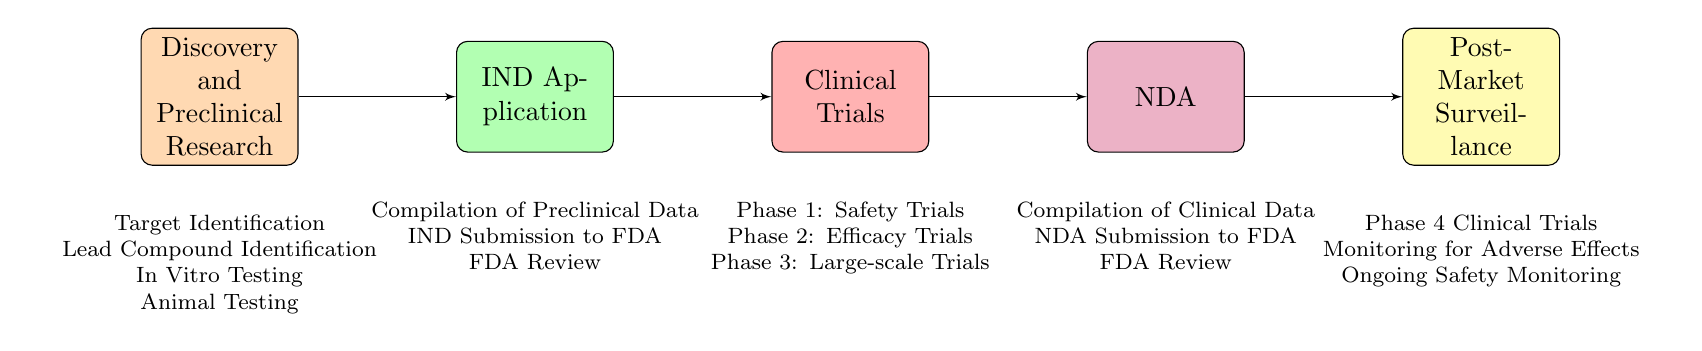What is the first stage in the drug development process? The diagram clearly lists "Discovery and Preclinical Research" as the first stage, as it is positioned leftmost in the flow chart and is not preceded by any other stage.
Answer: Discovery and Preclinical Research How many phases are involved in Clinical Trials? The Clinical Trials stage contains three distinct phases: Phase 1, Phase 2, and Phase 3, which are specifically enumerated in the diagram beneath this stage.
Answer: Three What is the last stage of the drug development process? The last stage is indicated by the rightmost block of the flow chart, which is "Post-Market Surveillance," signifying it follows all prior stages in the progression of drug approval.
Answer: Post-Market Surveillance Which stage follows the IND Application? According to the flow chart, the stage directly following the IND Application is "Clinical Trials," evidenced by the connecting line leading rightward from the IND Application block to the Clinical Trials block.
Answer: Clinical Trials What are the elements listed under the New Drug Application stage? The diagram specifies three elements under the NDA block: "Compilation of Clinical Data," "NDA Submission to FDA," and "FDA Review," which are arranged in a compact list format beneath the NDA stage.
Answer: Compilation of Clinical Data, NDA Submission to FDA, FDA Review What type of trials are conducted during Phase 1? The diagram includes a description beneath the Phase 1 label stating, "Safety Trials in Healthy Volunteers," clarifying the nature of trials conducted in this phase.
Answer: Safety Trials in Healthy Volunteers How does the drug development process transition from Clinical Trials to NDA? The transition from Clinical Trials to NDA occurs through a directional line that indicates a flow from "Clinical Trials" to "NDA," showing that NDA follows the completion of Clinical Trials.
Answer: By line connection What ongoing activities are listed under Post-Market Surveillance? The diagram details three ongoing activities under Post-Market Surveillance: "Phase 4 Clinical Trials," "Monitoring for Adverse Effects," and "Ongoing Safety Monitoring," presented as a list below this stage.
Answer: Phase 4 Clinical Trials, Monitoring for Adverse Effects, Ongoing Safety Monitoring What is the primary focus of Phase 2 in Clinical Trials? According to the description offered within the diagram, the primary focus of Phase 2 is outlined as "Efficacy Trials in Small Patient Groups," indicating trials dedicated to assessing the drug's effectiveness.
Answer: Efficacy Trials in Small Patient Groups 